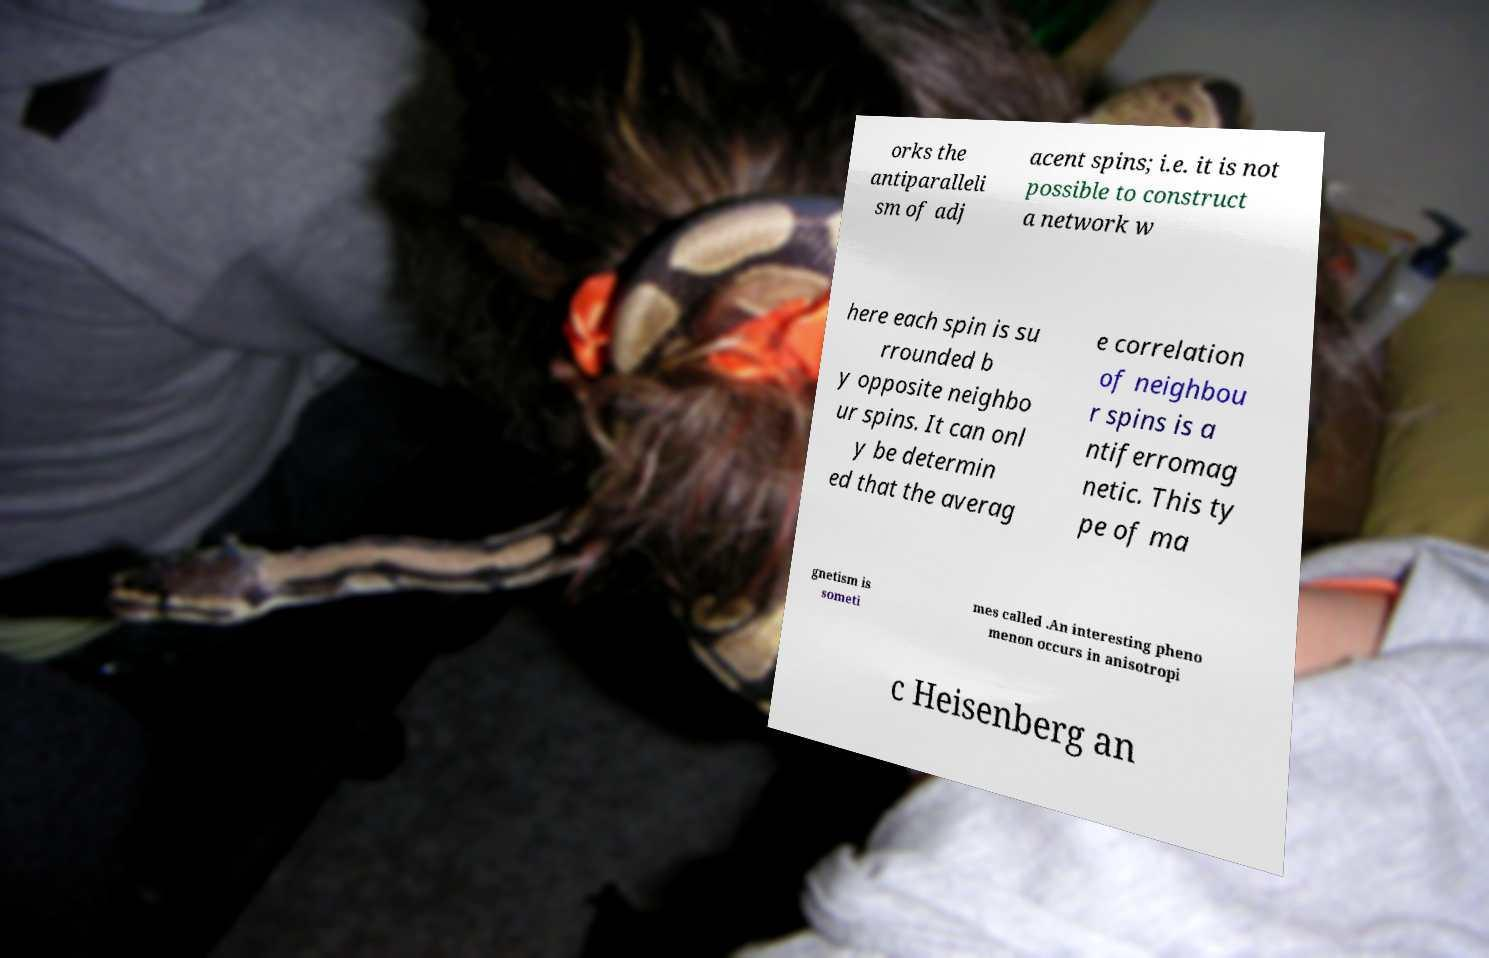Can you accurately transcribe the text from the provided image for me? orks the antiparalleli sm of adj acent spins; i.e. it is not possible to construct a network w here each spin is su rrounded b y opposite neighbo ur spins. It can onl y be determin ed that the averag e correlation of neighbou r spins is a ntiferromag netic. This ty pe of ma gnetism is someti mes called .An interesting pheno menon occurs in anisotropi c Heisenberg an 